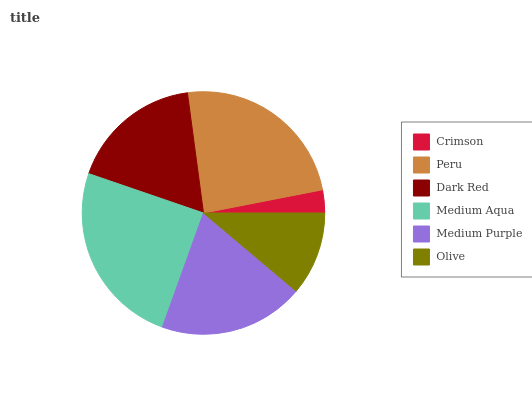Is Crimson the minimum?
Answer yes or no. Yes. Is Medium Aqua the maximum?
Answer yes or no. Yes. Is Peru the minimum?
Answer yes or no. No. Is Peru the maximum?
Answer yes or no. No. Is Peru greater than Crimson?
Answer yes or no. Yes. Is Crimson less than Peru?
Answer yes or no. Yes. Is Crimson greater than Peru?
Answer yes or no. No. Is Peru less than Crimson?
Answer yes or no. No. Is Medium Purple the high median?
Answer yes or no. Yes. Is Dark Red the low median?
Answer yes or no. Yes. Is Medium Aqua the high median?
Answer yes or no. No. Is Peru the low median?
Answer yes or no. No. 